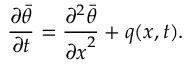<formula> <loc_0><loc_0><loc_500><loc_500>\frac { \partial \bar { \theta } } { \partial t } = \frac { \partial ^ { 2 } \bar { \theta } } { { \partial x } ^ { 2 } } + q ( x , t ) .</formula> 